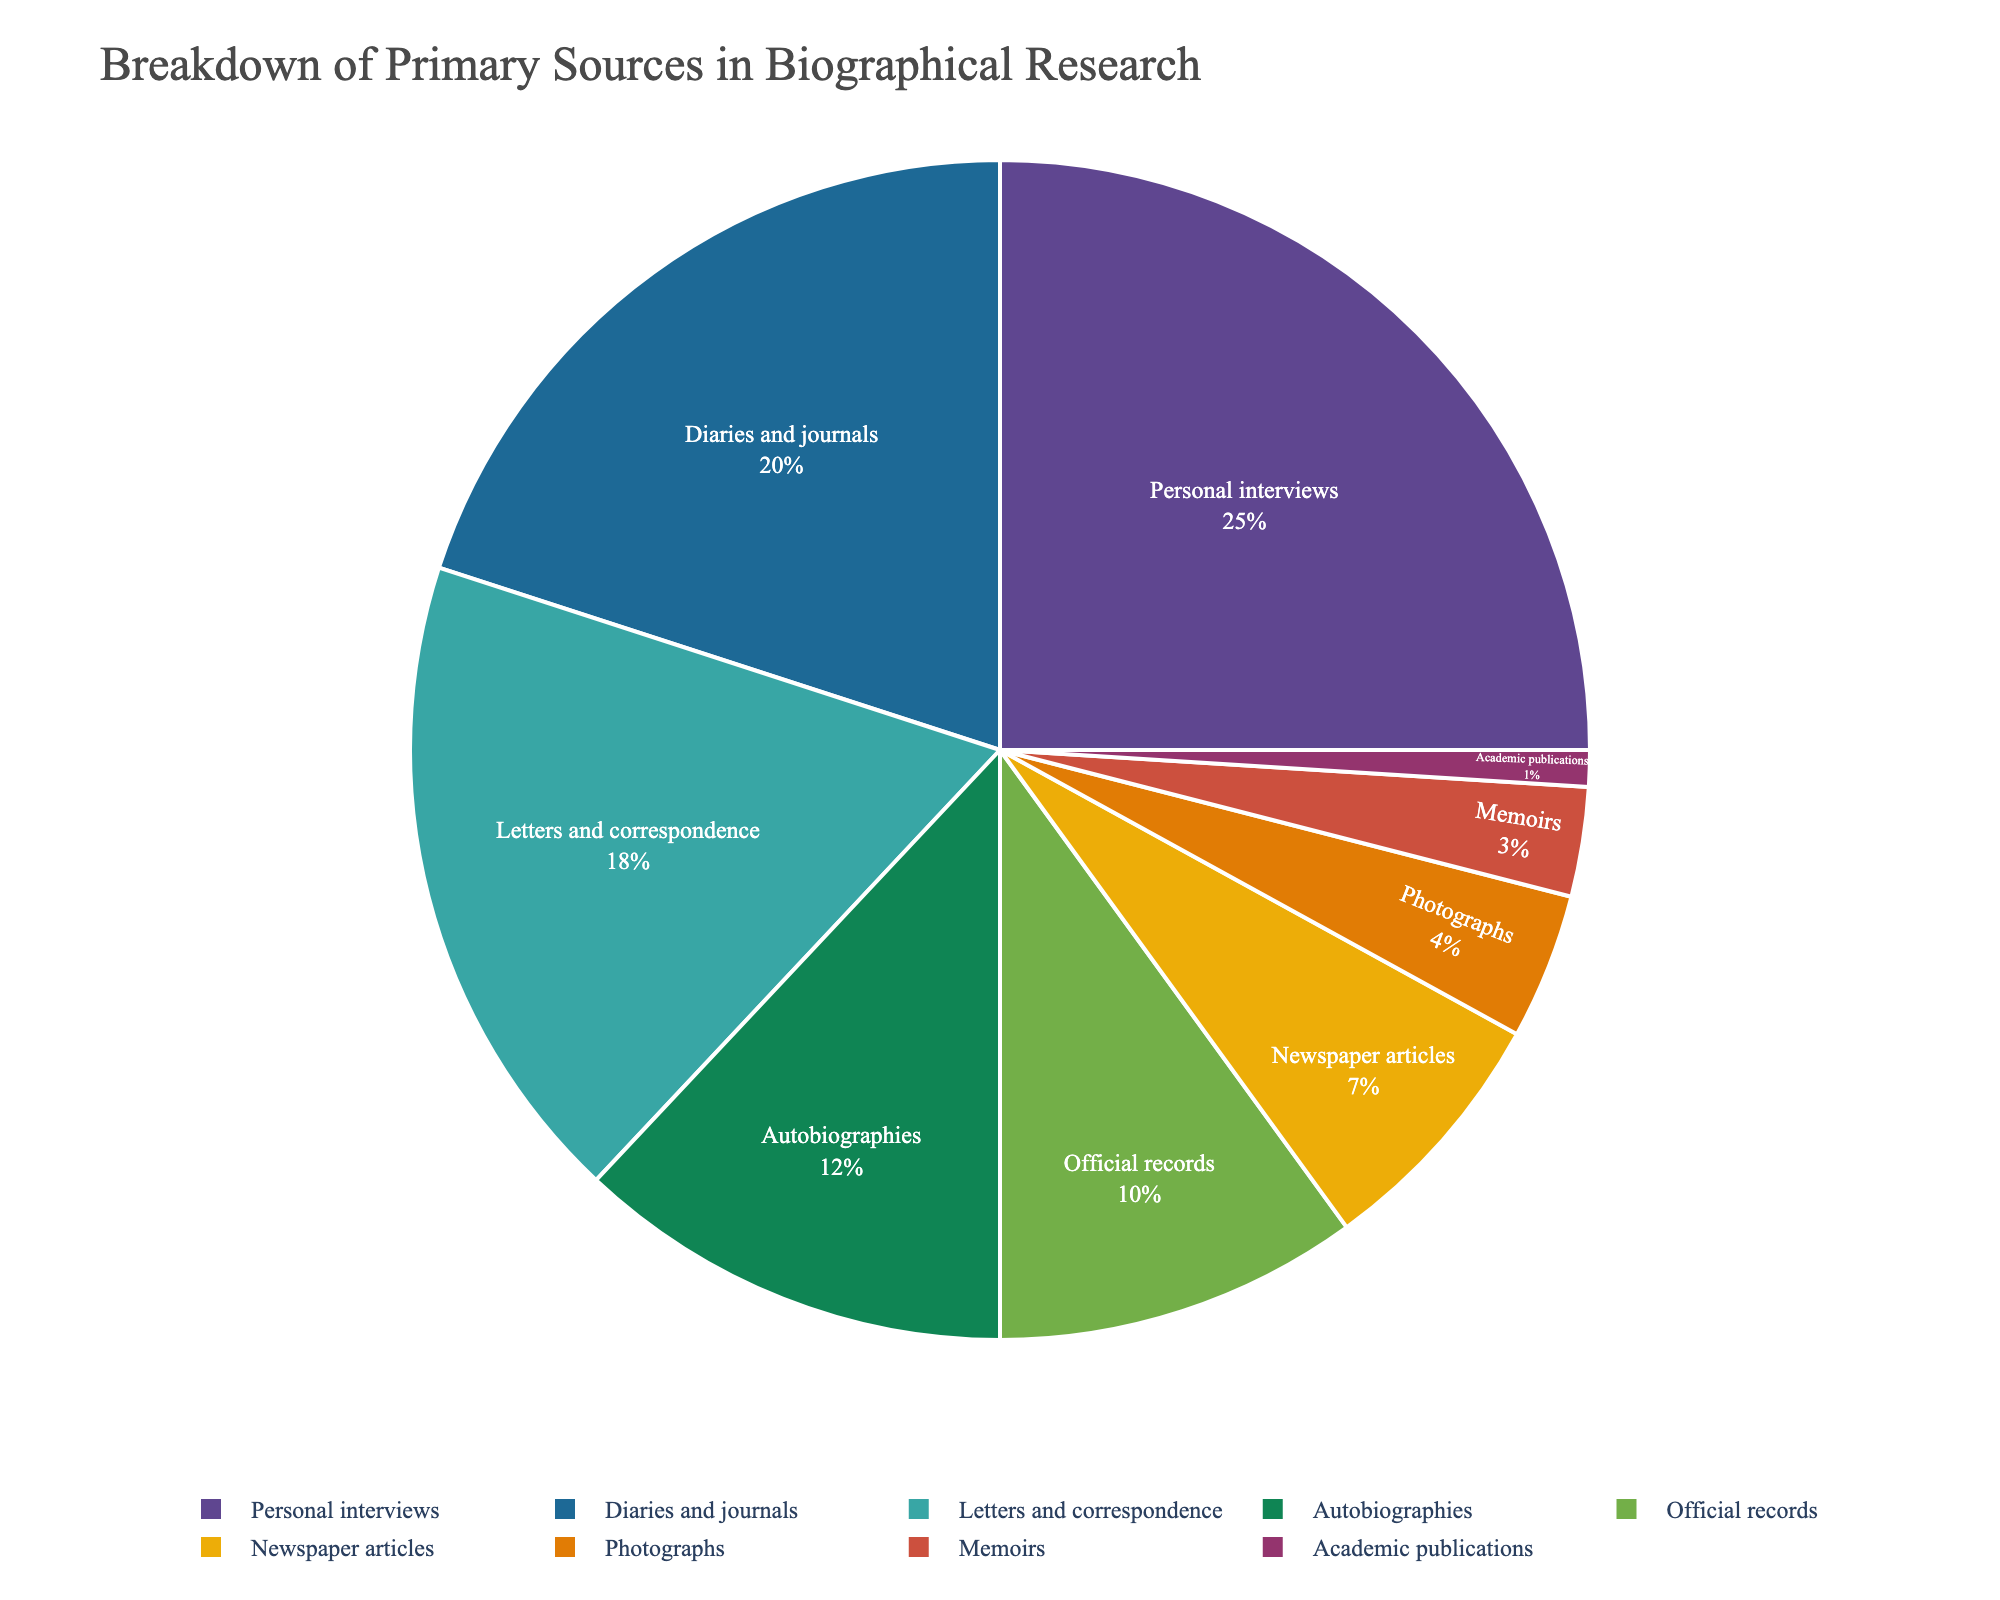what percentage of the primary sources are attributed to personal interviews and diaries and journals combined? To find the combined percentage, add the percentages for 'Personal interviews' (25%) and 'Diaries and journals' (20%). 25 + 20 = 45
Answer: 45% which category has a higher percentage, letters and correspondence or official records? Compare the percentages for 'Letters and Correspondence' (18%) and 'Official records' (10%). Since 18 > 10, 'Letters and Correspondence' has a higher percentage.
Answer: Letters and Correspondence what is the combined percentage of sources that contribute less than 10% each? Add the percentages of categories contributing less than 10%, which are 'Official records' (10%), 'Newspaper articles' (7%), 'Photographs' (4%), 'Memoirs' (3%), and 'Academic publications' (1%). 10 + 7 + 4 + 3 + 1 = 25
Answer: 25% if you combine autobiographies, newspaper articles, and memoirs, what is their total percentage contribution? Add the percentages for 'Autobiographies' (12%), 'Newspaper articles' (7%), and 'Memoirs' (3%). 12 + 7 + 3 = 22
Answer: 22% which primary source category has the smallest percentage contribution, and what is it? Identify the category with the smallest percentage by comparing all given percentages. 'Academic publications' has the smallest percentage at 1%.
Answer: Academic publications, 1% how many more percentage points do personal interviews contribute compared to newspaper articles? Subtract the percentage of 'Newspaper articles' (7%) from 'Personal interviews' (25%). 25 - 7 = 18
Answer: 18 which source contributes less than photographs but more than academic publications? 'Photographs' contribute 4% and 'Academic publications' contribute 1%. The category 'Memoirs' falls between these two with a contribution of 3%.
Answer: Memoirs what visual characteristics help you identify the category with the largest contribution? The category with the largest contribution will appear as the largest slice in the pie chart, often displayed near the top with a bright or prominent color. In this case, 'Personal interviews' is likely the largest slice and positioned prominently.
Answer: Largest slice, visually prominent if you remove official records and academic publications, what is the new total percentage? Subtract the percentages for 'Official records' (10%) and 'Academic publications' (1%) from the total (100%). 100 - 10 - 1 = 89
Answer: 89% which two categories combined contribute exactly half of the total percentage? Identify two categories whose combined percentage equals 50%. 'Personal interviews' contribute 25%, and 'Diaries and journals' contribute 20%. Combined, they equal 45%, so they do not meet the requirement. On further evaluation, no two categories combine exactly to 50%.
Answer: None 